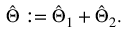Convert formula to latex. <formula><loc_0><loc_0><loc_500><loc_500>\begin{array} { r } { \hat { \Theta } \colon = \hat { \Theta } _ { 1 } + \hat { \Theta } _ { 2 } . } \end{array}</formula> 